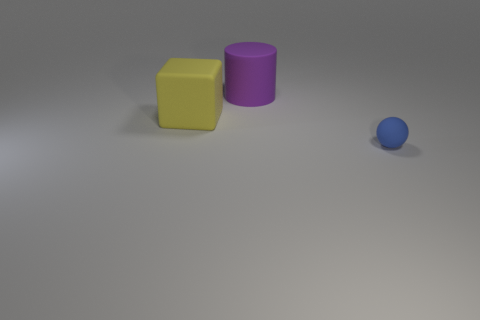There is another object that is the same size as the purple rubber object; what shape is it?
Your response must be concise. Cube. How many objects are large green rubber spheres or things that are to the left of the small blue matte thing?
Make the answer very short. 2. Do the big cube and the large cylinder have the same color?
Your answer should be compact. No. There is a large yellow rubber thing; what number of objects are behind it?
Your answer should be compact. 1. What is the color of the sphere that is the same material as the large purple cylinder?
Your answer should be very brief. Blue. How many rubber objects are large brown spheres or big purple cylinders?
Offer a terse response. 1. Do the tiny blue thing and the big purple cylinder have the same material?
Keep it short and to the point. Yes. There is a rubber thing that is in front of the yellow rubber thing; what shape is it?
Offer a terse response. Sphere. There is a matte thing that is behind the big yellow matte cube; are there any purple matte cylinders that are on the left side of it?
Your answer should be compact. No. Is there a cube that has the same size as the blue object?
Your response must be concise. No. 